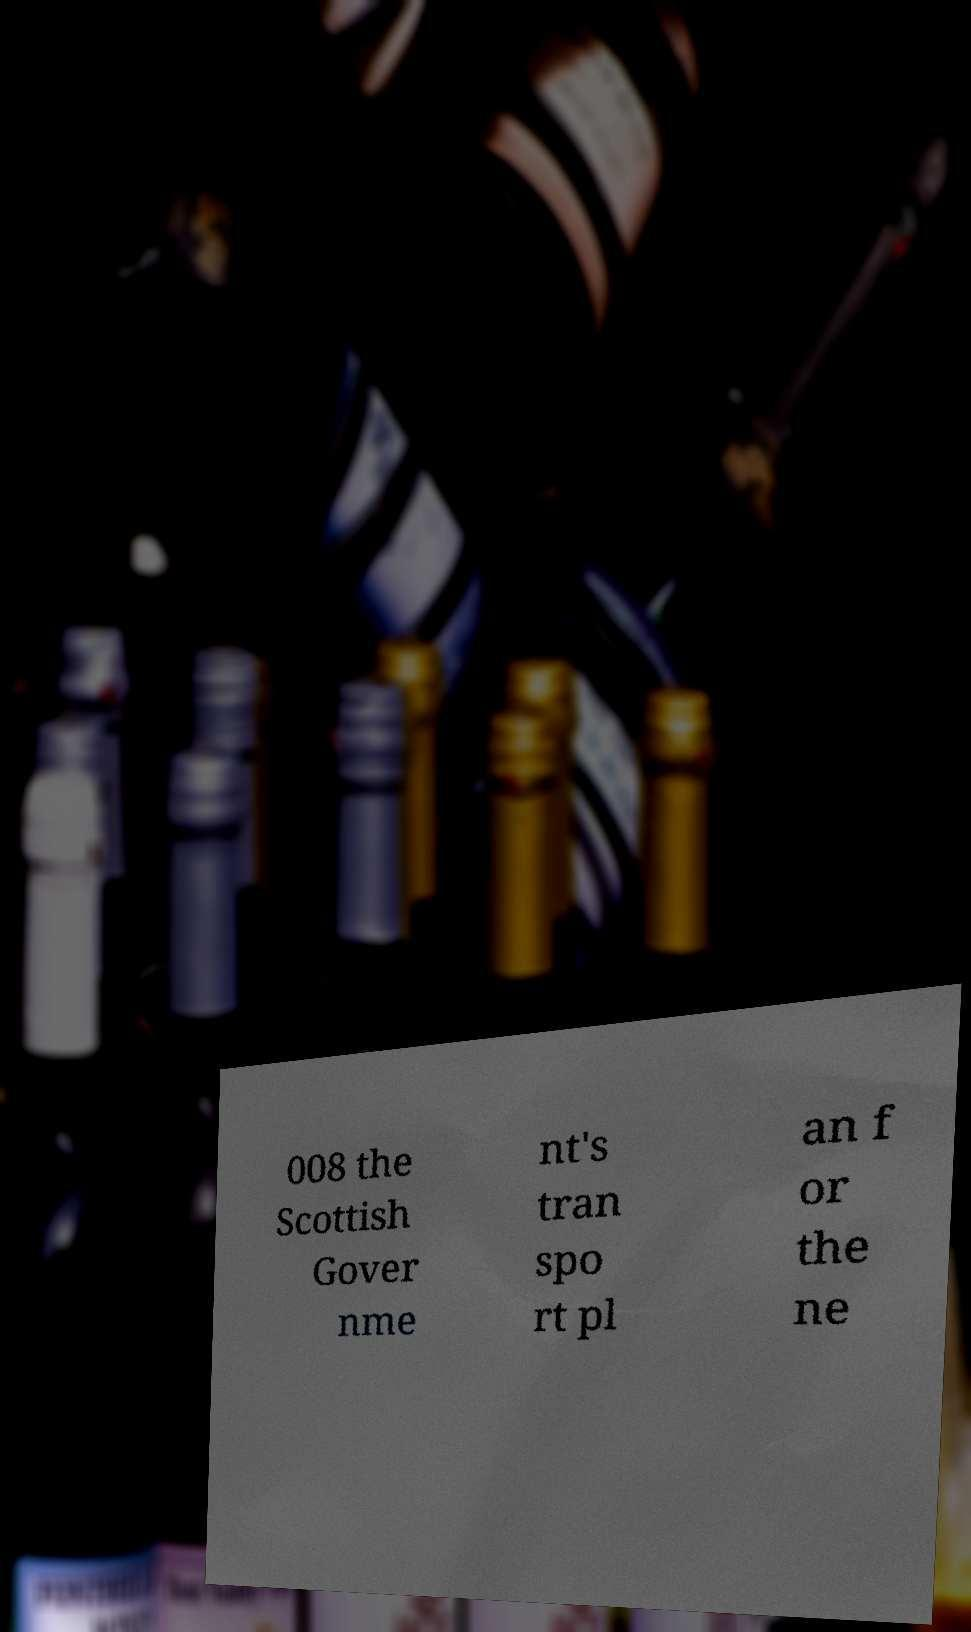For documentation purposes, I need the text within this image transcribed. Could you provide that? 008 the Scottish Gover nme nt's tran spo rt pl an f or the ne 